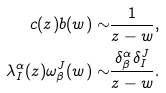<formula> <loc_0><loc_0><loc_500><loc_500>c ( z ) b ( w ) \sim & \frac { 1 } { z - w } , \\ \lambda ^ { \alpha } _ { I } ( z ) \omega _ { \beta } ^ { J } ( w ) \sim & \frac { \delta ^ { \alpha } _ { \beta } \delta ^ { J } _ { I } } { z - w } .</formula> 